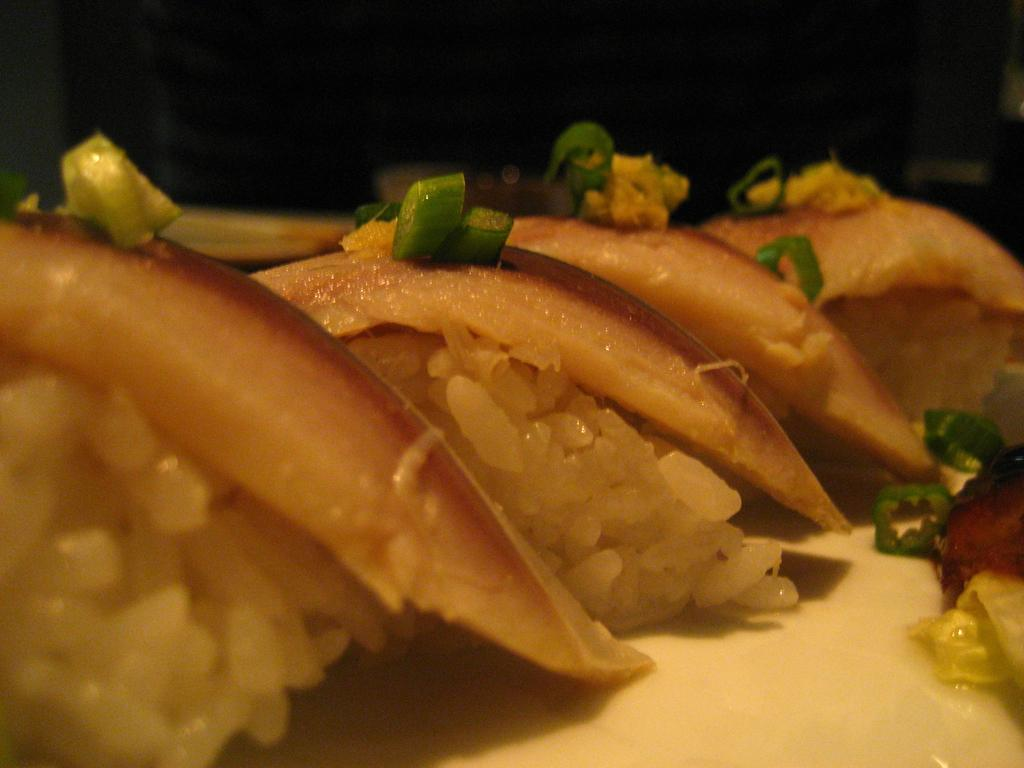What types of objects can be seen in the image? There are food items in the image. Can you describe the background of the image? The background of the image is dark. What effect does the mine have on the food items in the image? There is no mine present in the image, so it cannot have any effect on the food items. 